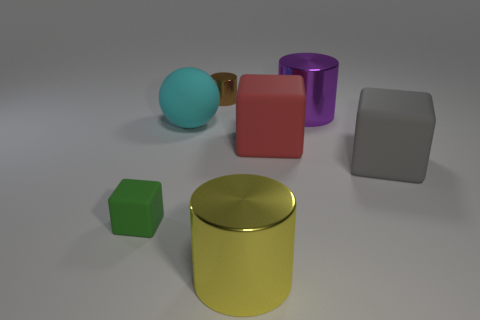Subtract all brown cylinders. How many cylinders are left? 2 Subtract all red matte cubes. How many cubes are left? 2 Subtract 3 cylinders. How many cylinders are left? 0 Subtract all purple cylinders. Subtract all red cubes. How many cylinders are left? 2 Subtract all yellow blocks. How many blue balls are left? 0 Subtract all big yellow metal cylinders. Subtract all matte spheres. How many objects are left? 5 Add 5 large cyan objects. How many large cyan objects are left? 6 Add 6 tiny green spheres. How many tiny green spheres exist? 6 Add 2 metallic things. How many objects exist? 9 Subtract 0 purple blocks. How many objects are left? 7 